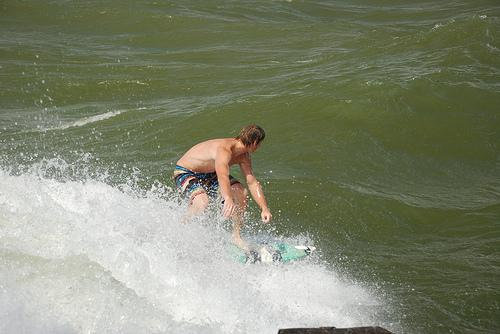List the colors of the shorts the man is wearing while surfing. Blue, yellow, red, and black. In your own words, describe the wave the surfer is riding. The man is surfing on a frothy, white wave with some green water around it. Describe the position of the man while he is surfing. The man is leaning over and bent forward while surfing on the wave. Identify the primary activity taking place in the image. A man is surfing on a wave in the ocean. Mention the features of the surfboard used by the surfer. The surfboard is green, white, and black. How many hands of the man can be identified in the image and what positions they are in? Two hands can be identified: right hand and left hand in fist positions. What type of hairstyle does the man have in the image? The man has short brown hair. Provide a brief description of the man's appearance. The man has brown hair, is shirtless, and wears colorful shorts. State three distinctive colors present in the image. Green, white, and blue. State the environment in which the man is surfing. The man is surfing in green and white ocean waves. Identify the attributes of the man's hair. Brown and short hair. Is the water in the image pink and transparent? No, it's not mentioned in the image. Evaluate the overall quality of the image. High quality with clear details and good contrast. Detect any unusual elements or anomalies within the image. There are no significant anomalies detected in the image. Determine the sentiment or feeling conveyed by the image. Exciting and adventurous. Determine the location of the man's left and right feet in the image. Left foot at (229, 231), unable to determine the location of the right foot. Provide a detailed description of the surfboard. The surfboard is green, white, and black in color; 103x103 size in the image. Find any textual information present in the image. There is no text present in the image. Analyze the interaction between the man and the ocean waves. The man is skillfully surfing on the white waves in green water. Deduce the color and texture of the wave the man is surfing on. The wave is white and frothy. In the context of the image, are the waves more green or white? The waves are more white. Which object is the man leaning on? A green, white, and black surfboard. Identify the main activity taking place in the image. A man is surfing in the ocean. Describe the color of the water in the image. The water is green and dark. Classify the type of surfing the man is doing. The man is leaning over and bending while surfing. Pinpoint the location of the left and right hands of the man. Left hand at (258, 207), right hand at (220, 199). Segment the image based on the semantic areas present. Man, ocean, waves, surfboard, and shorts. What is the man wearing while surfing? Colorful shorts and no shirt. Estimate the sizes of the ocean waves in the background. Various sizes, between 35 to 91 in width and 35 to 91 in height. 